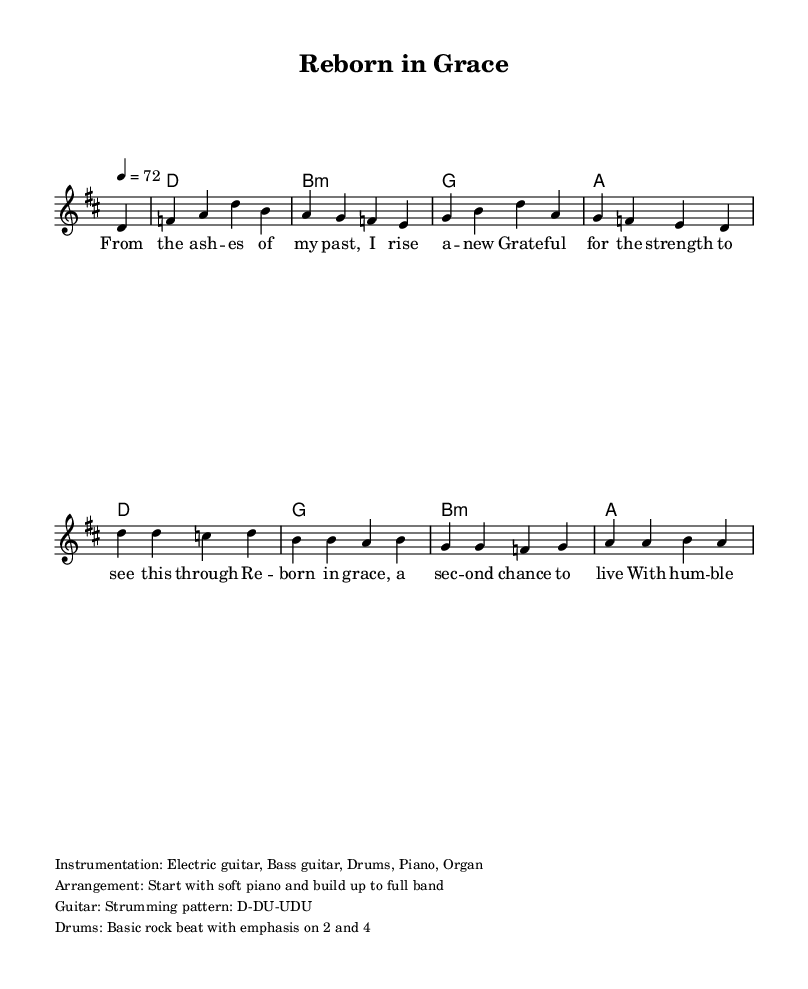What is the key signature of this music? The key signature indicates that the piece is in D major, which has two sharps (F# and C#). This can be inferred from the initial indication before the staff begins.
Answer: D major What is the time signature of this music? The time signature appears at the beginning of the sheet music and indicates it is 4/4. This means there are four beats in each measure.
Answer: 4/4 What is the tempo marking given? The tempo marking is shown at the start of the music, indicating a tempo of 72 beats per minute, which helps in understanding the speed of the piece.
Answer: 72 How many measures are in the melody section? The melody section is comprised of a total of eight measures, as counted from the beginning to the end of the melody line provided.
Answer: Eight measures What instruments are specified for this arrangement? The instrumentation is noted at the end of the sheet music and lists electric guitar, bass guitar, drums, piano, and organ. This gives a clear idea of the musical ensemble.
Answer: Electric guitar, Bass guitar, Drums, Piano, Organ Which lyric section expresses themes of rebirth and gratitude? The verse words from the lyrics clearly express themes of rebirth and gratitude, highlighted by the lines "From the ashes of my past, I rise anew" and "Grateful for the strength to see this through." This reflects the piece's core message.
Answer: Verse What musical element indicates a progression towards a full band? The arrangement note states that the piece should start with soft piano and then build up to a full band, indicating a dynamic transition in the performance.
Answer: Build up to full band 